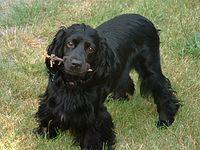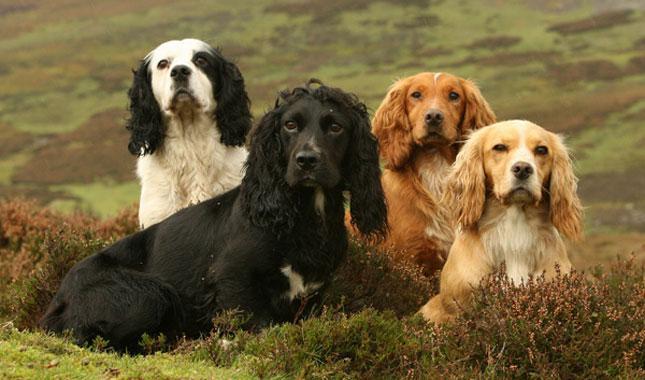The first image is the image on the left, the second image is the image on the right. Examine the images to the left and right. Is the description "At least two dogs are sitting int he grass." accurate? Answer yes or no. Yes. The first image is the image on the left, the second image is the image on the right. Analyze the images presented: Is the assertion "An image includes a white dog with black ears, and includes more than one dog." valid? Answer yes or no. Yes. 